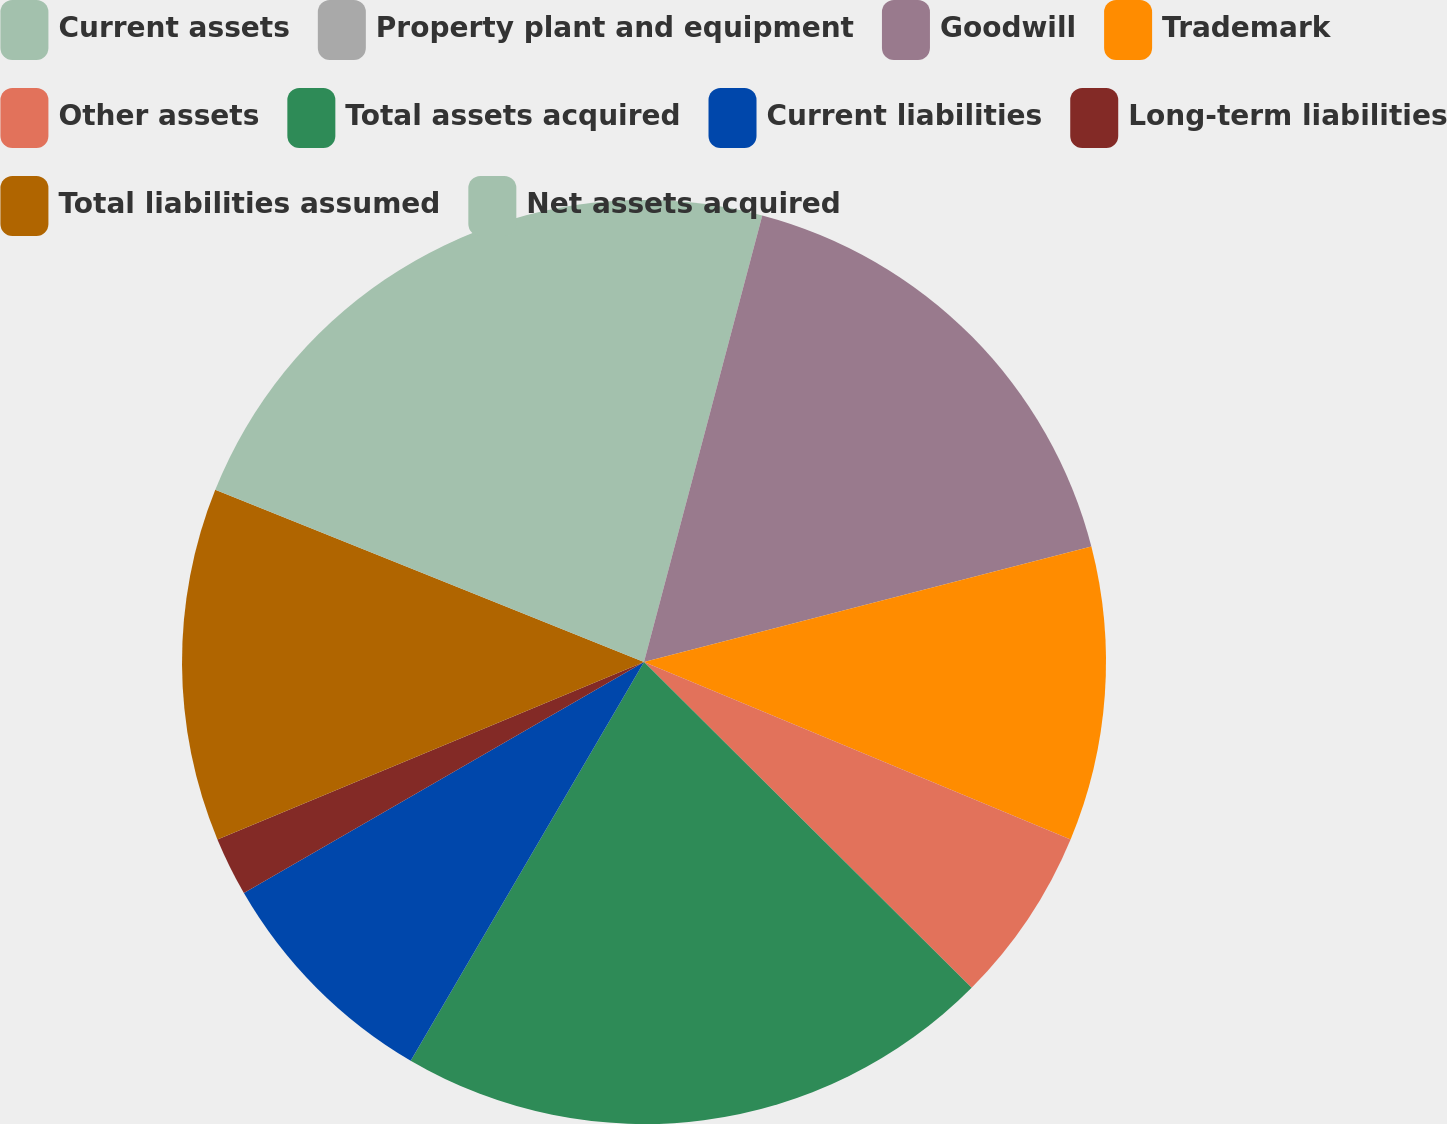Convert chart. <chart><loc_0><loc_0><loc_500><loc_500><pie_chart><fcel>Current assets<fcel>Property plant and equipment<fcel>Goodwill<fcel>Trademark<fcel>Other assets<fcel>Total assets acquired<fcel>Current liabilities<fcel>Long-term liabilities<fcel>Total liabilities assumed<fcel>Net assets acquired<nl><fcel>4.12%<fcel>0.0%<fcel>16.86%<fcel>10.29%<fcel>6.18%<fcel>20.97%<fcel>8.24%<fcel>2.06%<fcel>12.35%<fcel>18.92%<nl></chart> 